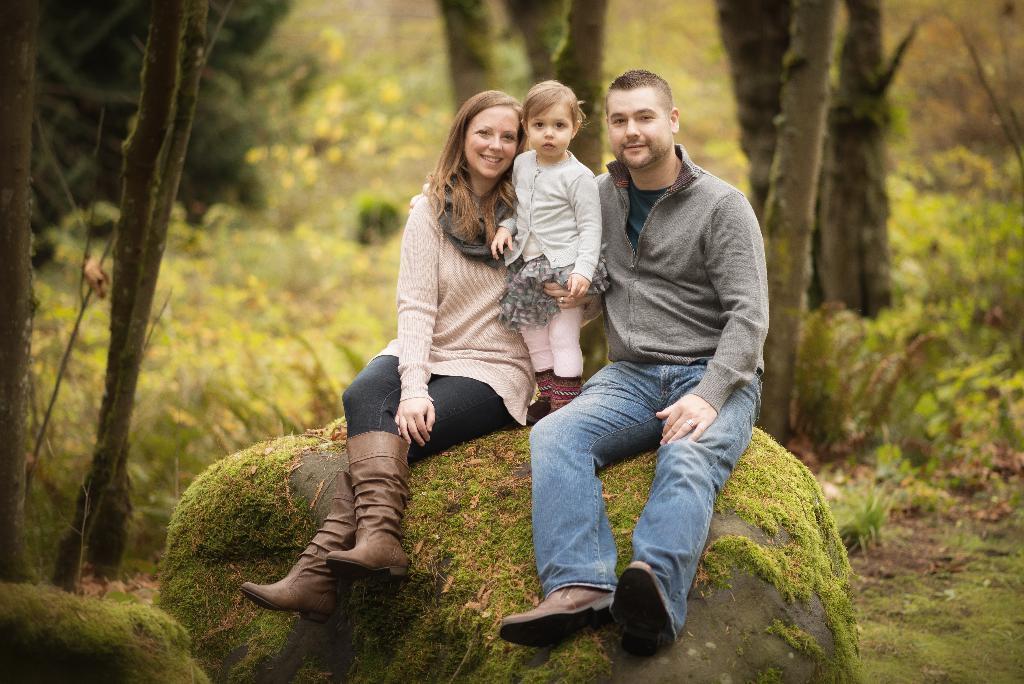Describe this image in one or two sentences. This picture shows a man and a woman seated on the rock and we see a girl standing and we see woman holding the girl and we see trees and grass on the ground and few plants. 